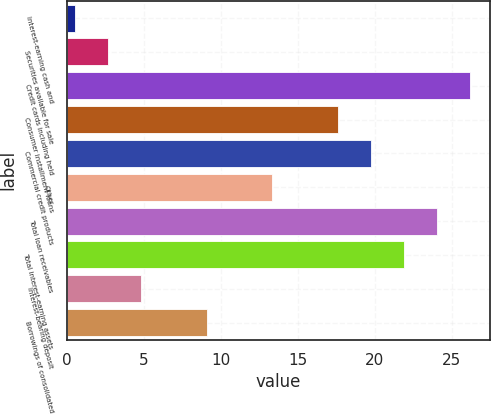<chart> <loc_0><loc_0><loc_500><loc_500><bar_chart><fcel>Interest-earning cash and<fcel>Securities available for sale<fcel>Credit cards including held<fcel>Consumer installment loans<fcel>Commercial credit products<fcel>Other<fcel>Total loan receivables<fcel>Total interest-earning assets<fcel>Interest-bearing deposit<fcel>Borrowings of consolidated<nl><fcel>0.52<fcel>2.66<fcel>26.16<fcel>17.6<fcel>19.74<fcel>13.33<fcel>24.02<fcel>21.88<fcel>4.79<fcel>9.06<nl></chart> 